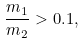<formula> <loc_0><loc_0><loc_500><loc_500>\frac { m _ { 1 } } { m _ { 2 } } > 0 . 1 , \label H { e q \colon c o n d i t i o n - g l o b a l - m a s s }</formula> 